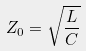Convert formula to latex. <formula><loc_0><loc_0><loc_500><loc_500>Z _ { 0 } = \sqrt { \frac { L } { C } }</formula> 